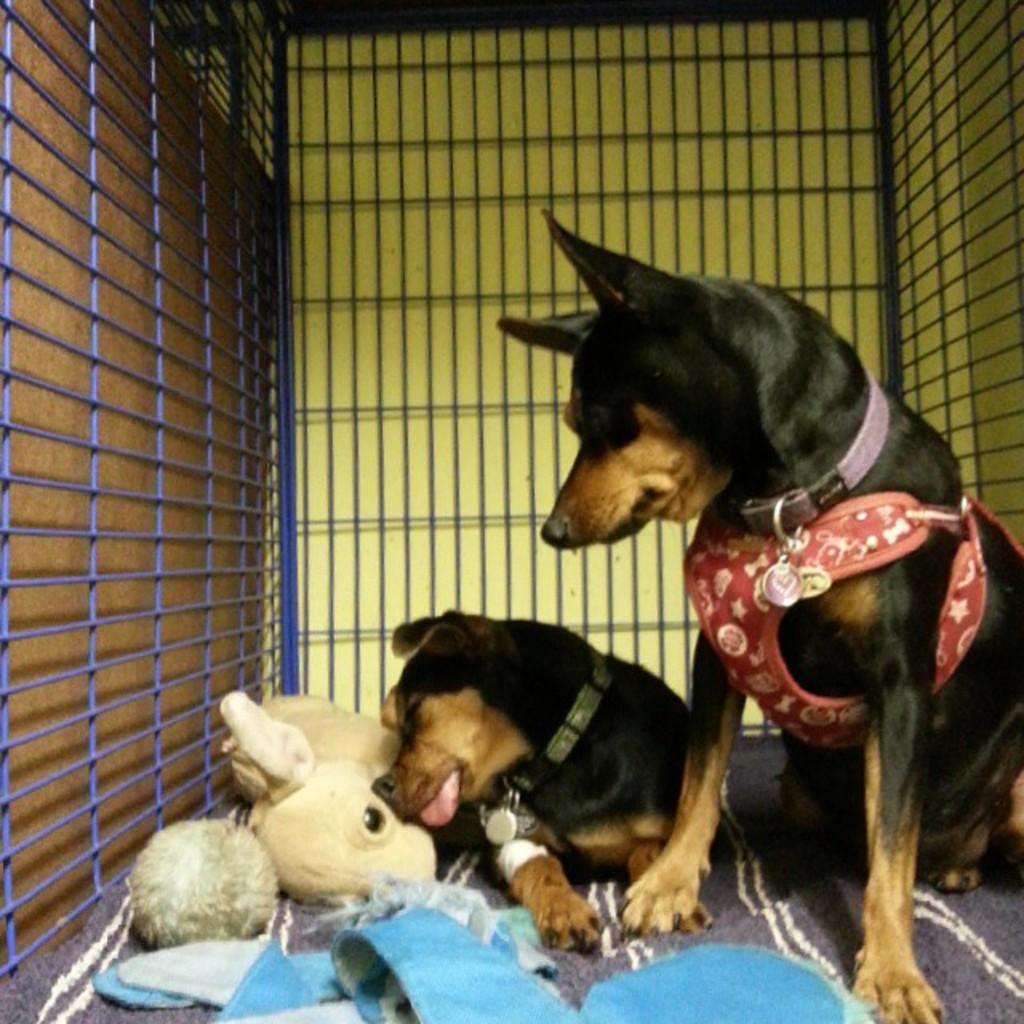How many dogs are present in the image? There are 2 dogs in the image. Where are the dogs located? The dogs are in a cage. What can be seen around the dogs' necks? The dogs have belts around their necks. What additional object can be seen in the image? There is a soft toy in the image. What type of nail is being used by the dogs in the image? There is no nail present in the image; the dogs have belts around their necks. How does the image depict the dogs' digestion process? The image does not show or describe the dogs' digestion process. 